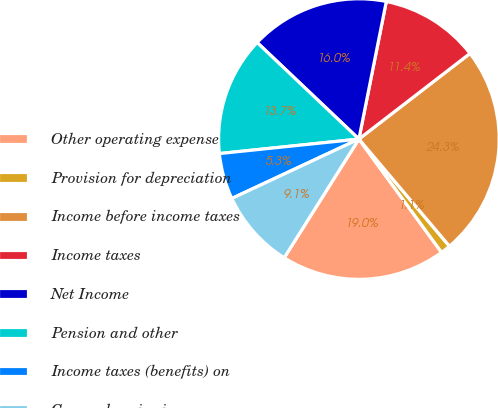<chart> <loc_0><loc_0><loc_500><loc_500><pie_chart><fcel>Other operating expense<fcel>Provision for depreciation<fcel>Income before income taxes<fcel>Income taxes<fcel>Net Income<fcel>Pension and other<fcel>Income taxes (benefits) on<fcel>Comprehensive income<nl><fcel>18.97%<fcel>1.14%<fcel>24.28%<fcel>11.42%<fcel>16.05%<fcel>13.73%<fcel>5.31%<fcel>9.1%<nl></chart> 